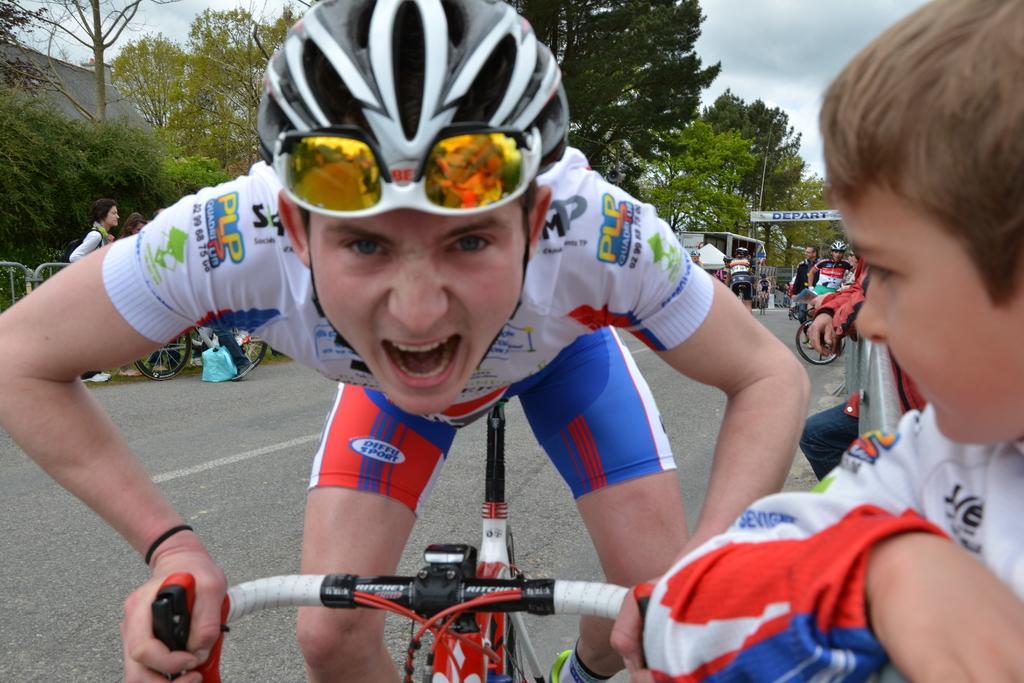Describe this image in one or two sentences. This is a picture taken in the outdoors. It is sunny. The man in white t shirt was riding a bike on road. background of the man is trees and sky. 